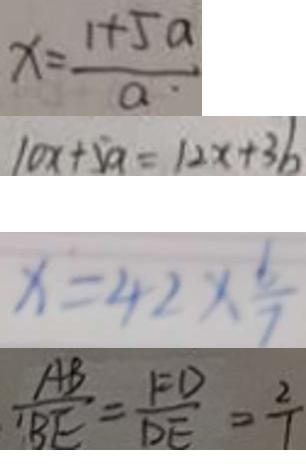<formula> <loc_0><loc_0><loc_500><loc_500>x = \frac { 1 + 5 a } { a } 
 1 0 x + 5 a = 1 2 x + 3 b 
 x = 4 2 \times \frac { 6 } { 7 } 
 \frac { A B } { B E } = \frac { F D } { D E } = \frac { 2 } { 1 }</formula> 